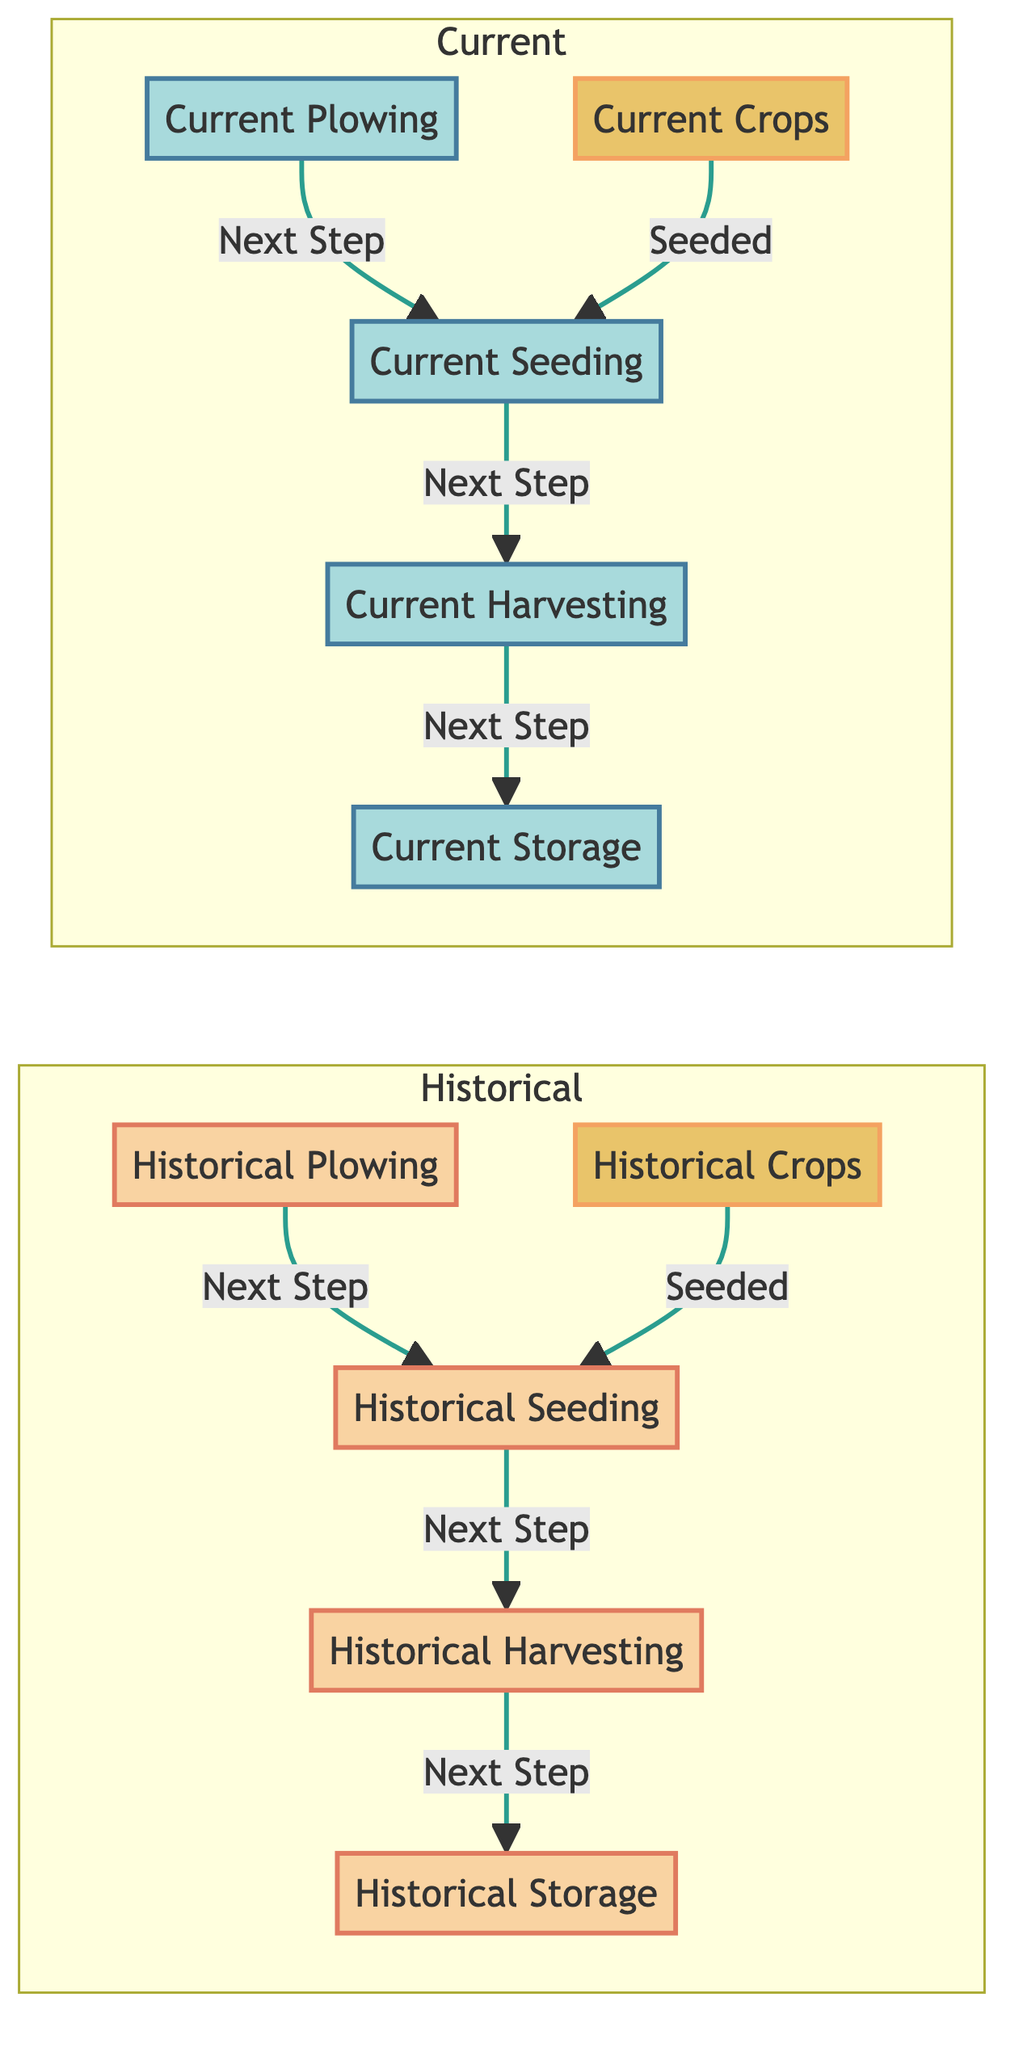What are the steps in historical farming practices? The steps are: Historical Plowing, Historical Seeding, Historical Harvesting, Historical Storage. This sequence is derived from the upward arrows indicating the process flow.
Answer: Historical Plowing, Historical Seeding, Historical Harvesting, Historical Storage How many nodes are in the "Current" subgraph? The "Current" subgraph contains four nodes: Current Plowing, Current Seeding, Current Harvesting, Current Storage. To identify this, we simply count the nodes present within the Current category.
Answer: 4 What is the first step in current agricultural systems? The first step is Current Plowing, as it is the starting node in the Current subgraph, indicated by its position in the flow.
Answer: Current Plowing Which historical crop leads to seeding? Historical Crops lead to Historical Seeding, as indicated by the connection between these two nodes in the diagram.
Answer: Historical Crops How many edges connect the nodes in the "Current" subgraph? There are three edges in the Current subgraph: from Current Plowing to Current Seeding, from Current Seeding to Current Harvesting, and from Current Harvesting to Current Storage. Each step shows a direct connection, indicating the progression.
Answer: 3 What is the last step in historical farming practices? The last step is Historical Storage, as indicated by the direction of the arrows leading from Historical Harvesting to Historical Storage.
Answer: Historical Storage Which node's function is to store in current agriculture? The node is Current Storage, as it is explicitly labeled as the storage function within the Current subgraph, following Current Harvesting.
Answer: Current Storage What relationship exists between Current Harvesting and Historical Harvesting? Both are labeled as harvesting steps in their respective subgraphs, but they are distinct processes in different systems—Current Harvesting in present-day practices and Historical Harvesting in traditional methods.
Answer: Different processes 